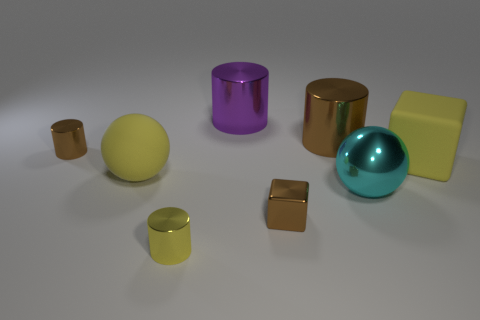Is the number of small yellow metal objects on the right side of the tiny brown cube less than the number of large green matte cylinders?
Offer a terse response. No. What shape is the purple object that is made of the same material as the cyan thing?
Provide a short and direct response. Cylinder. Does the small brown cube have the same material as the large yellow sphere?
Provide a short and direct response. No. Are there fewer metallic blocks that are to the left of the yellow cylinder than yellow things that are to the left of the large cyan metal object?
Offer a very short reply. Yes. There is a metallic cylinder that is the same color as the matte cube; what size is it?
Provide a short and direct response. Small. How many large yellow balls are behind the big yellow rubber thing behind the large matte thing that is left of the brown metal cube?
Give a very brief answer. 0. Is the color of the rubber ball the same as the big matte cube?
Make the answer very short. Yes. Are there any metal spheres that have the same color as the matte block?
Make the answer very short. No. There is a metallic ball that is the same size as the purple cylinder; what color is it?
Make the answer very short. Cyan. Are there any other large objects of the same shape as the big brown thing?
Keep it short and to the point. Yes. 